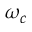<formula> <loc_0><loc_0><loc_500><loc_500>\omega _ { c }</formula> 